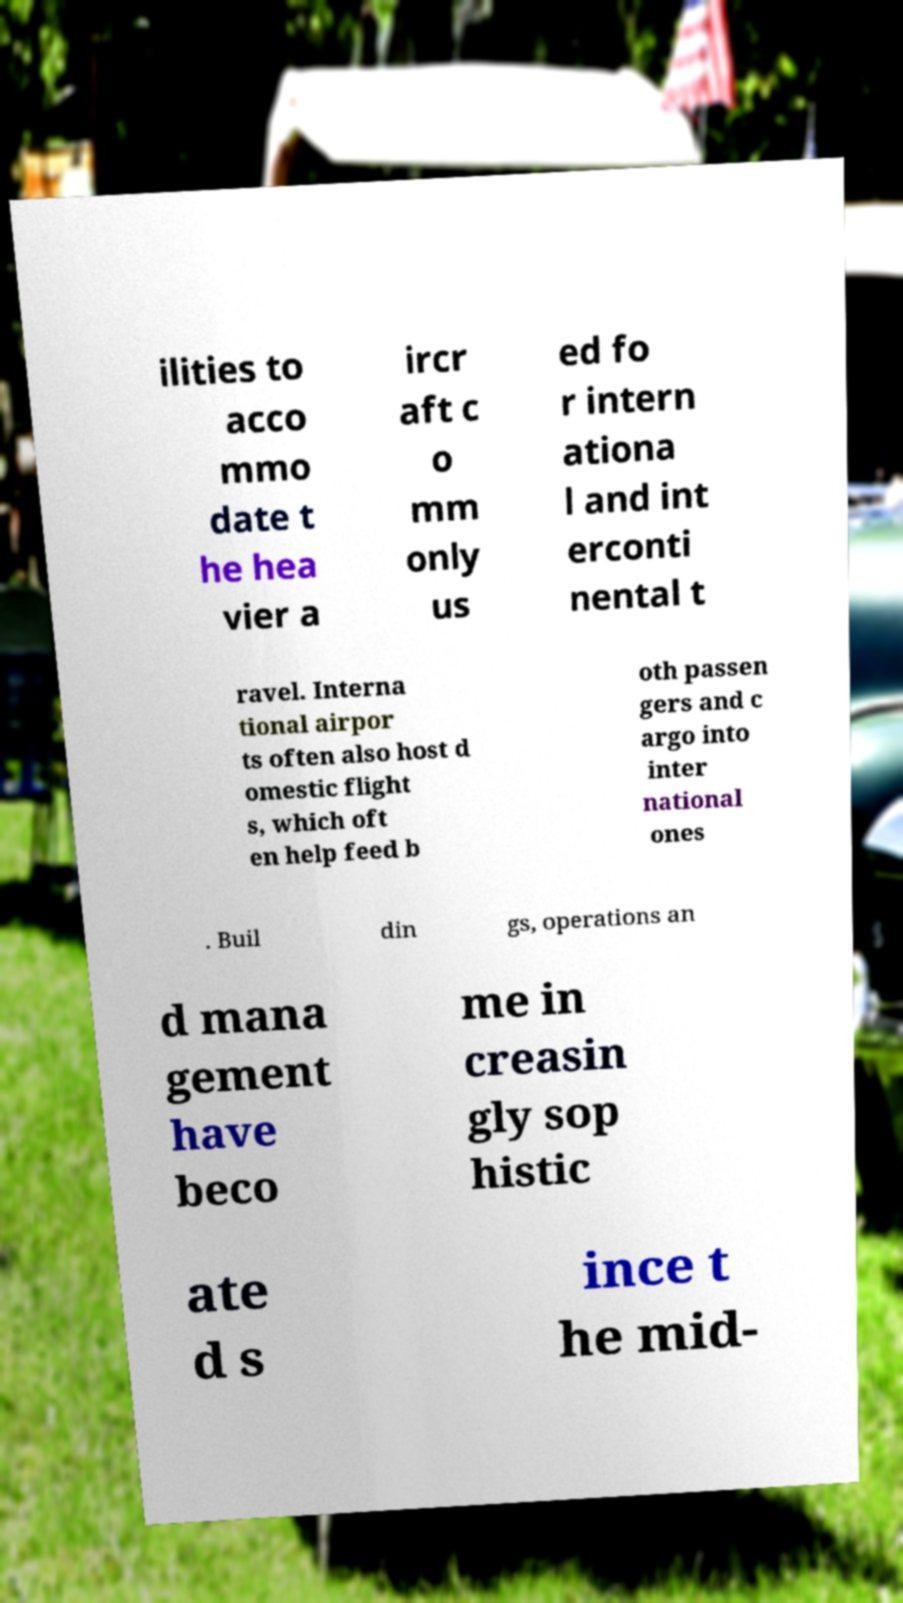Please identify and transcribe the text found in this image. ilities to acco mmo date t he hea vier a ircr aft c o mm only us ed fo r intern ationa l and int erconti nental t ravel. Interna tional airpor ts often also host d omestic flight s, which oft en help feed b oth passen gers and c argo into inter national ones . Buil din gs, operations an d mana gement have beco me in creasin gly sop histic ate d s ince t he mid- 